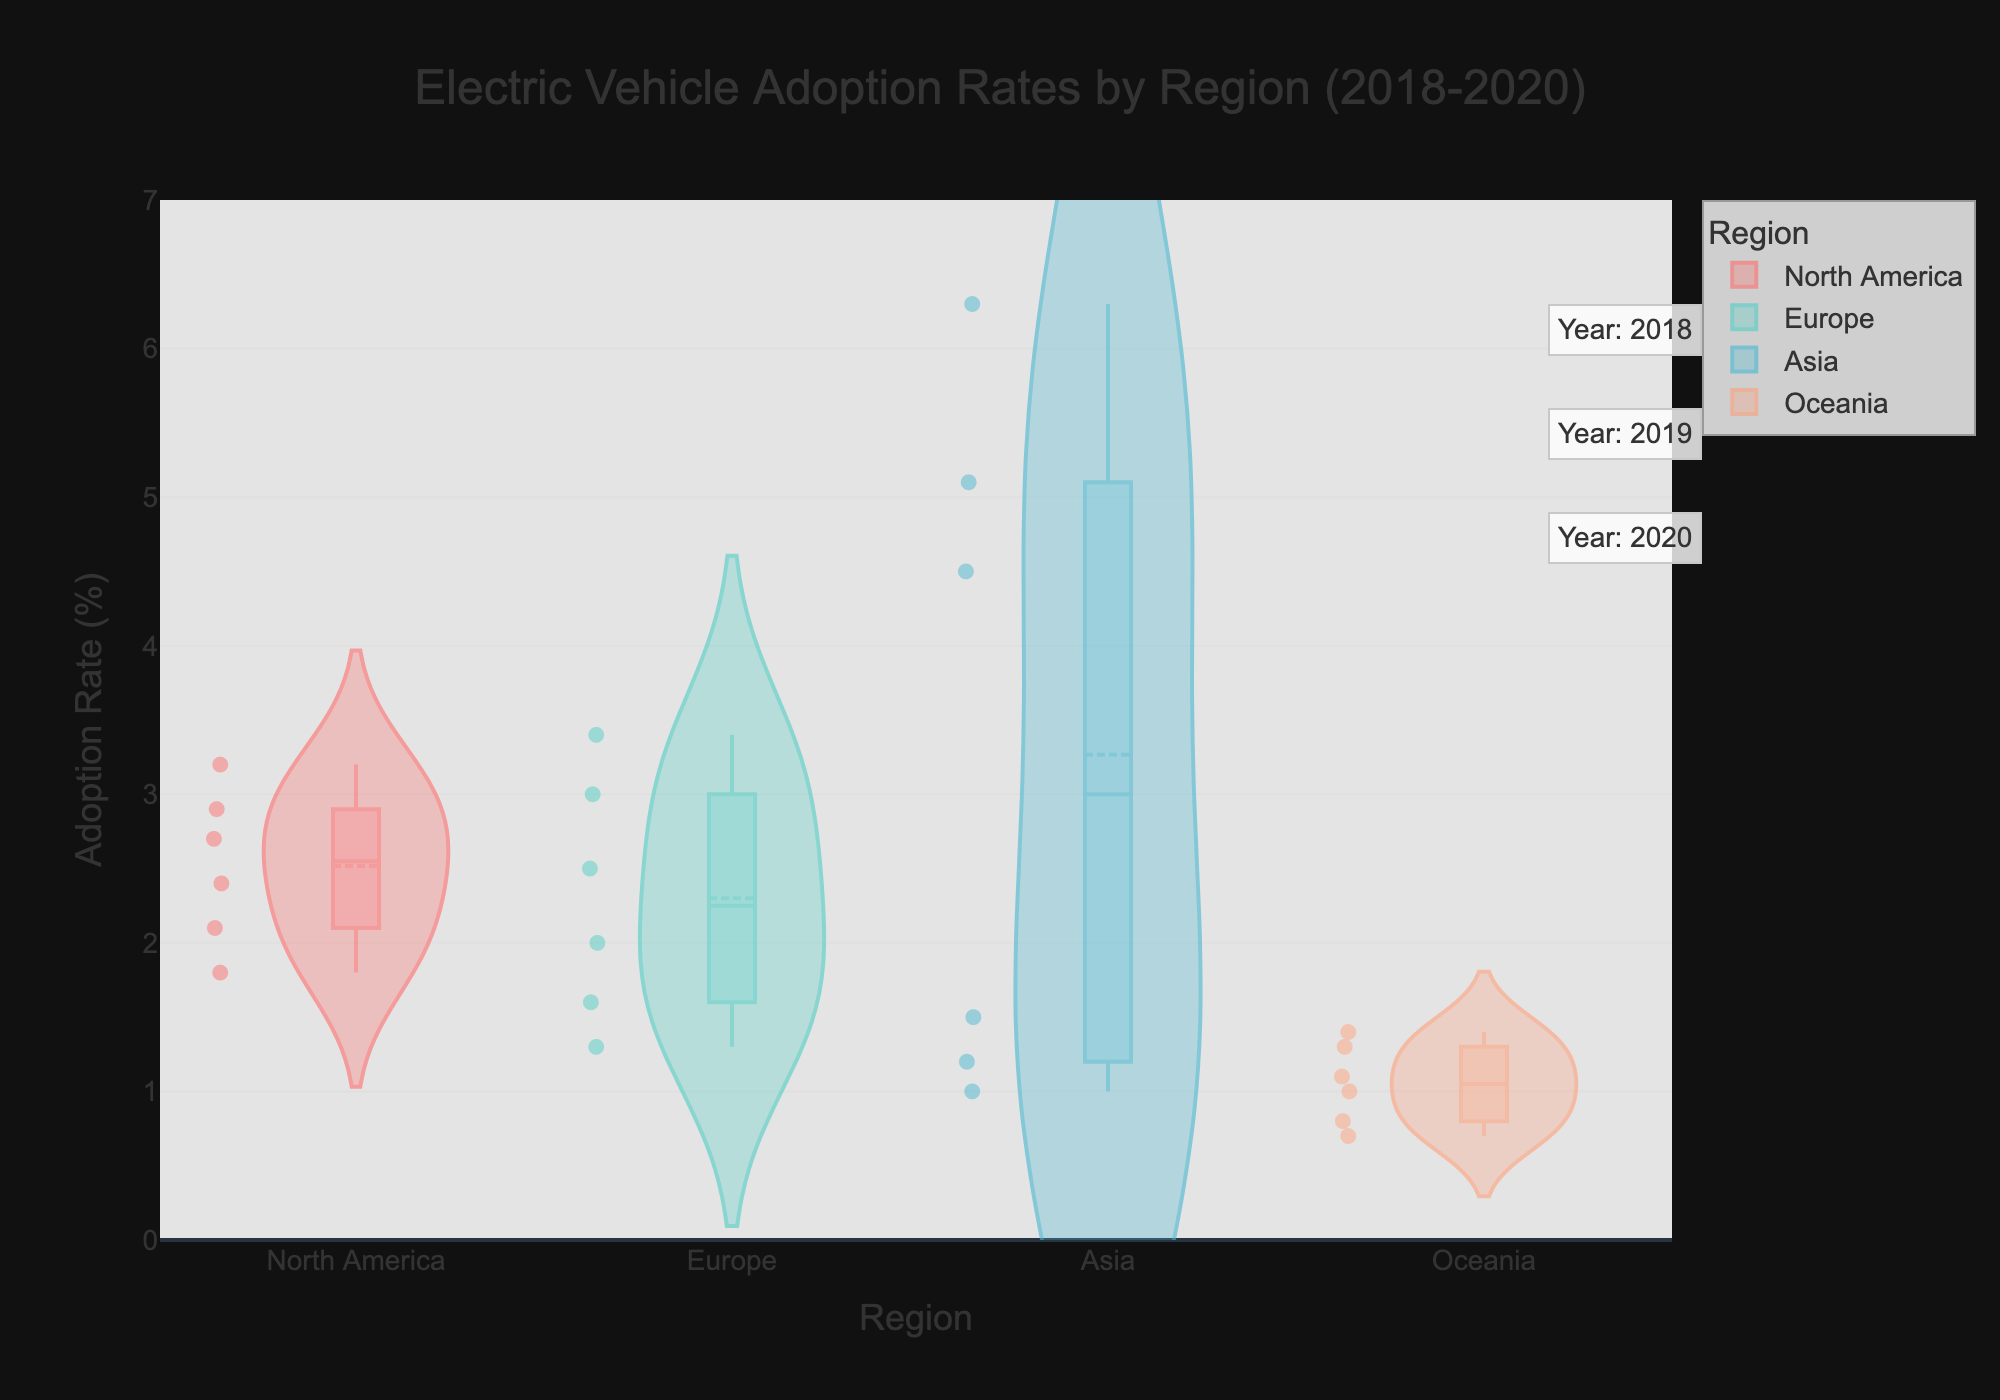What's the title of the figure? The title is prominently displayed at the top of the figure. It reads "Electric Vehicle Adoption Rates by Region (2018-2020)."
Answer: Electric Vehicle Adoption Rates by Region (2018-2020) What is the y-axis title? The y-axis title is positioned beside the y-axis and indicates the metric being measured. It is "Adoption Rate (%)".
Answer: Adoption Rate (%) Which region has the highest median adoption rate? The highest median adoption rate is shown by the horizontal line in the center of each violin plot's box plot. Asia has the highest median, which is particularly noticeable due to China's high adoption rates.
Answer: Asia Which region shows the greatest variability in adoption rates? Variability can be assessed by the width and spread of the violin plot. Europe appears to have the greatest variability, particularly due to significant differences in adoption rates between Germany and the United Kingdom.
Answer: Europe How does the adoption rate in Oceania compare between 2018 and 2020? To compare adoption rates over these years, look at the spread of data points on the violin plot for Oceania. The adoption rate has increased from 0.7-0.8% in 2018 to 1.3-1.4% in 2020.
Answer: It increased What can be inferred about electric vehicle adoption in North America? North America's box plot shows a moderate increase in adoption rates from 2018 to 2020, with values clustering between 1.8% and 3.2%. The violin plot's shape suggests incremental yearly increases.
Answer: Increasing trend Considering the mean adoption rates, how does Europe compare to Asia? The mean line inside the violin plots of Europe and Asia indicates their average adoption rates. Asia has a higher mean adoption rate compared to Europe, largely due to China's high rates.
Answer: Asia has higher mean Which country within North America shows a higher adoption rate in 2020? North America consists of the United States and Canada. By 2020, the United States has a slightly higher adoption rate (3.2%) compared to Canada (2.7%).
Answer: United States What does the width of the violin plot indicate about adoption rates in each region? The width of the violin plot at any given y-value indicates the density of data points at that adoption rate. A wider section means more countries within that region have similar adoption rates.
Answer: Density of data points 